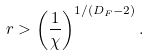<formula> <loc_0><loc_0><loc_500><loc_500>r > \left ( \frac { 1 } { \chi } \right ) ^ { 1 / ( D _ { F } - 2 ) } .</formula> 